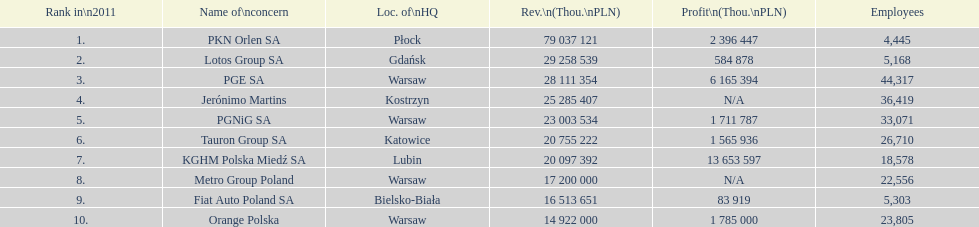Which company had the least revenue? Orange Polska. 